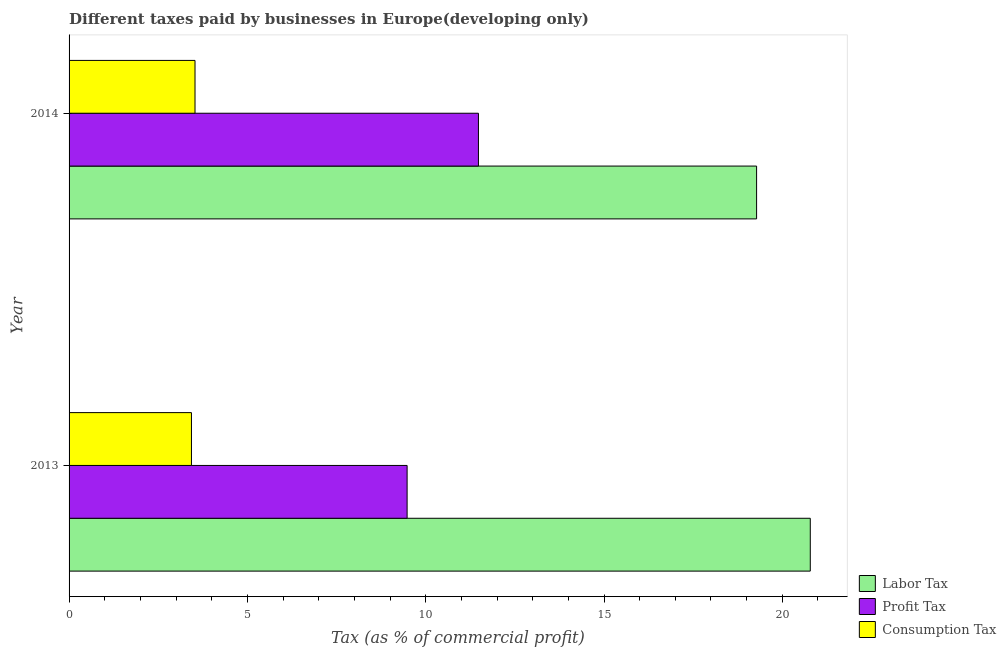Are the number of bars per tick equal to the number of legend labels?
Make the answer very short. Yes. Are the number of bars on each tick of the Y-axis equal?
Offer a terse response. Yes. How many bars are there on the 2nd tick from the top?
Provide a succinct answer. 3. What is the percentage of consumption tax in 2014?
Provide a short and direct response. 3.53. Across all years, what is the maximum percentage of labor tax?
Your response must be concise. 20.78. Across all years, what is the minimum percentage of labor tax?
Your answer should be compact. 19.28. In which year was the percentage of labor tax maximum?
Offer a very short reply. 2013. What is the total percentage of consumption tax in the graph?
Your answer should be compact. 6.96. What is the difference between the percentage of consumption tax in 2013 and that in 2014?
Make the answer very short. -0.1. What is the difference between the percentage of labor tax in 2013 and the percentage of profit tax in 2014?
Give a very brief answer. 9.31. What is the average percentage of consumption tax per year?
Provide a short and direct response. 3.48. In the year 2013, what is the difference between the percentage of consumption tax and percentage of profit tax?
Your response must be concise. -6.05. In how many years, is the percentage of profit tax greater than 17 %?
Your answer should be compact. 0. What is the ratio of the percentage of profit tax in 2013 to that in 2014?
Offer a terse response. 0.83. Is the percentage of profit tax in 2013 less than that in 2014?
Your answer should be compact. Yes. In how many years, is the percentage of profit tax greater than the average percentage of profit tax taken over all years?
Offer a very short reply. 1. What does the 1st bar from the top in 2013 represents?
Provide a short and direct response. Consumption Tax. What does the 2nd bar from the bottom in 2013 represents?
Keep it short and to the point. Profit Tax. Is it the case that in every year, the sum of the percentage of labor tax and percentage of profit tax is greater than the percentage of consumption tax?
Provide a short and direct response. Yes. Are all the bars in the graph horizontal?
Your response must be concise. Yes. How many years are there in the graph?
Your response must be concise. 2. Where does the legend appear in the graph?
Provide a short and direct response. Bottom right. How many legend labels are there?
Provide a short and direct response. 3. What is the title of the graph?
Keep it short and to the point. Different taxes paid by businesses in Europe(developing only). Does "Capital account" appear as one of the legend labels in the graph?
Make the answer very short. No. What is the label or title of the X-axis?
Ensure brevity in your answer.  Tax (as % of commercial profit). What is the label or title of the Y-axis?
Your answer should be very brief. Year. What is the Tax (as % of commercial profit) of Labor Tax in 2013?
Your answer should be very brief. 20.78. What is the Tax (as % of commercial profit) in Profit Tax in 2013?
Your response must be concise. 9.48. What is the Tax (as % of commercial profit) of Consumption Tax in 2013?
Make the answer very short. 3.43. What is the Tax (as % of commercial profit) of Labor Tax in 2014?
Make the answer very short. 19.28. What is the Tax (as % of commercial profit) in Profit Tax in 2014?
Offer a very short reply. 11.48. What is the Tax (as % of commercial profit) in Consumption Tax in 2014?
Keep it short and to the point. 3.53. Across all years, what is the maximum Tax (as % of commercial profit) of Labor Tax?
Ensure brevity in your answer.  20.78. Across all years, what is the maximum Tax (as % of commercial profit) in Profit Tax?
Provide a short and direct response. 11.48. Across all years, what is the maximum Tax (as % of commercial profit) in Consumption Tax?
Keep it short and to the point. 3.53. Across all years, what is the minimum Tax (as % of commercial profit) in Labor Tax?
Ensure brevity in your answer.  19.28. Across all years, what is the minimum Tax (as % of commercial profit) in Profit Tax?
Offer a terse response. 9.48. Across all years, what is the minimum Tax (as % of commercial profit) of Consumption Tax?
Provide a succinct answer. 3.43. What is the total Tax (as % of commercial profit) in Labor Tax in the graph?
Give a very brief answer. 40.06. What is the total Tax (as % of commercial profit) in Profit Tax in the graph?
Give a very brief answer. 20.96. What is the total Tax (as % of commercial profit) of Consumption Tax in the graph?
Ensure brevity in your answer.  6.96. What is the difference between the Tax (as % of commercial profit) of Labor Tax in 2013 and that in 2014?
Keep it short and to the point. 1.51. What is the difference between the Tax (as % of commercial profit) of Profit Tax in 2013 and that in 2014?
Offer a terse response. -2. What is the difference between the Tax (as % of commercial profit) in Consumption Tax in 2013 and that in 2014?
Give a very brief answer. -0.1. What is the difference between the Tax (as % of commercial profit) in Labor Tax in 2013 and the Tax (as % of commercial profit) in Profit Tax in 2014?
Your response must be concise. 9.31. What is the difference between the Tax (as % of commercial profit) of Labor Tax in 2013 and the Tax (as % of commercial profit) of Consumption Tax in 2014?
Keep it short and to the point. 17.25. What is the difference between the Tax (as % of commercial profit) of Profit Tax in 2013 and the Tax (as % of commercial profit) of Consumption Tax in 2014?
Your answer should be compact. 5.95. What is the average Tax (as % of commercial profit) of Labor Tax per year?
Keep it short and to the point. 20.03. What is the average Tax (as % of commercial profit) of Profit Tax per year?
Provide a succinct answer. 10.48. What is the average Tax (as % of commercial profit) of Consumption Tax per year?
Make the answer very short. 3.48. In the year 2013, what is the difference between the Tax (as % of commercial profit) in Labor Tax and Tax (as % of commercial profit) in Profit Tax?
Give a very brief answer. 11.31. In the year 2013, what is the difference between the Tax (as % of commercial profit) in Labor Tax and Tax (as % of commercial profit) in Consumption Tax?
Ensure brevity in your answer.  17.35. In the year 2013, what is the difference between the Tax (as % of commercial profit) of Profit Tax and Tax (as % of commercial profit) of Consumption Tax?
Your answer should be very brief. 6.05. In the year 2014, what is the difference between the Tax (as % of commercial profit) of Labor Tax and Tax (as % of commercial profit) of Consumption Tax?
Your answer should be compact. 15.75. In the year 2014, what is the difference between the Tax (as % of commercial profit) of Profit Tax and Tax (as % of commercial profit) of Consumption Tax?
Your answer should be very brief. 7.95. What is the ratio of the Tax (as % of commercial profit) of Labor Tax in 2013 to that in 2014?
Offer a terse response. 1.08. What is the ratio of the Tax (as % of commercial profit) of Profit Tax in 2013 to that in 2014?
Your answer should be compact. 0.83. What is the ratio of the Tax (as % of commercial profit) of Consumption Tax in 2013 to that in 2014?
Your response must be concise. 0.97. What is the difference between the highest and the second highest Tax (as % of commercial profit) of Labor Tax?
Your response must be concise. 1.51. What is the difference between the highest and the second highest Tax (as % of commercial profit) of Consumption Tax?
Give a very brief answer. 0.1. What is the difference between the highest and the lowest Tax (as % of commercial profit) of Labor Tax?
Your answer should be compact. 1.51. What is the difference between the highest and the lowest Tax (as % of commercial profit) in Consumption Tax?
Your response must be concise. 0.1. 